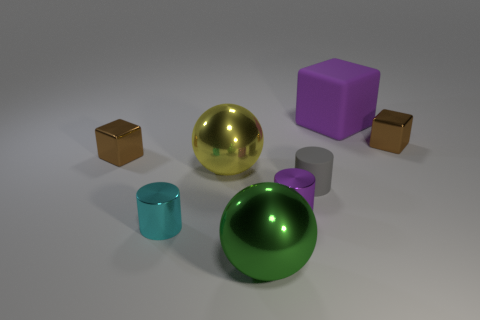There is a small object that is the same color as the large rubber block; what is its shape?
Make the answer very short. Cylinder. Do the large thing on the right side of the large green ball and the block to the left of the yellow metallic ball have the same color?
Provide a short and direct response. No. How many shiny things are both on the right side of the cyan shiny cylinder and behind the cyan thing?
Offer a terse response. 3. What is the small purple thing made of?
Your answer should be compact. Metal. What is the shape of the cyan metal thing that is the same size as the gray cylinder?
Your response must be concise. Cylinder. Are the purple thing that is behind the big yellow metallic sphere and the sphere in front of the small cyan metal thing made of the same material?
Offer a terse response. No. What number of small cyan metal cylinders are there?
Your answer should be very brief. 1. What number of large green things have the same shape as the tiny matte object?
Your answer should be compact. 0. Does the tiny cyan metallic thing have the same shape as the big matte object?
Keep it short and to the point. No. How big is the gray rubber thing?
Keep it short and to the point. Small. 